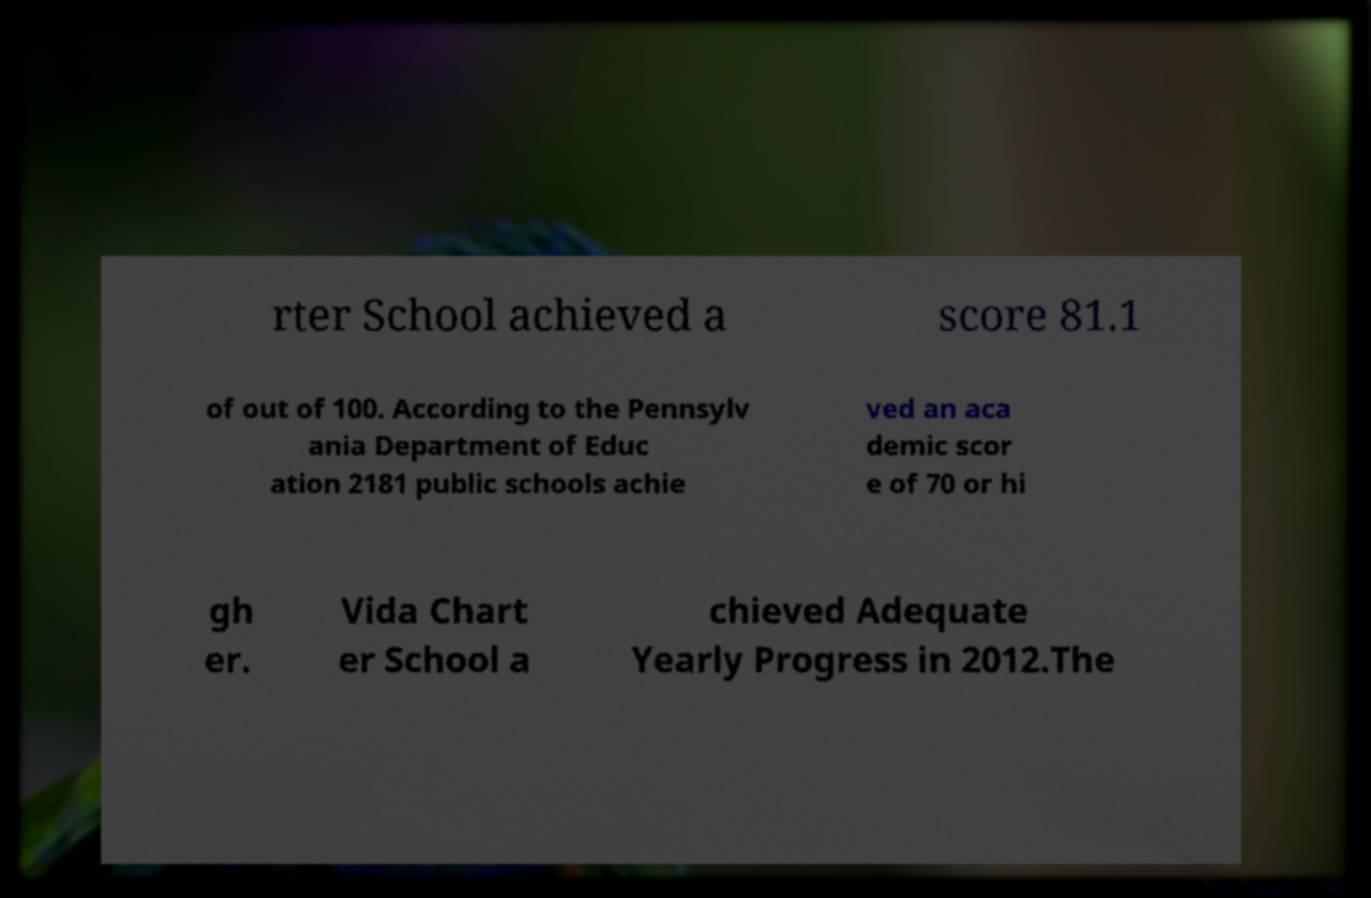I need the written content from this picture converted into text. Can you do that? rter School achieved a score 81.1 of out of 100. According to the Pennsylv ania Department of Educ ation 2181 public schools achie ved an aca demic scor e of 70 or hi gh er. Vida Chart er School a chieved Adequate Yearly Progress in 2012.The 